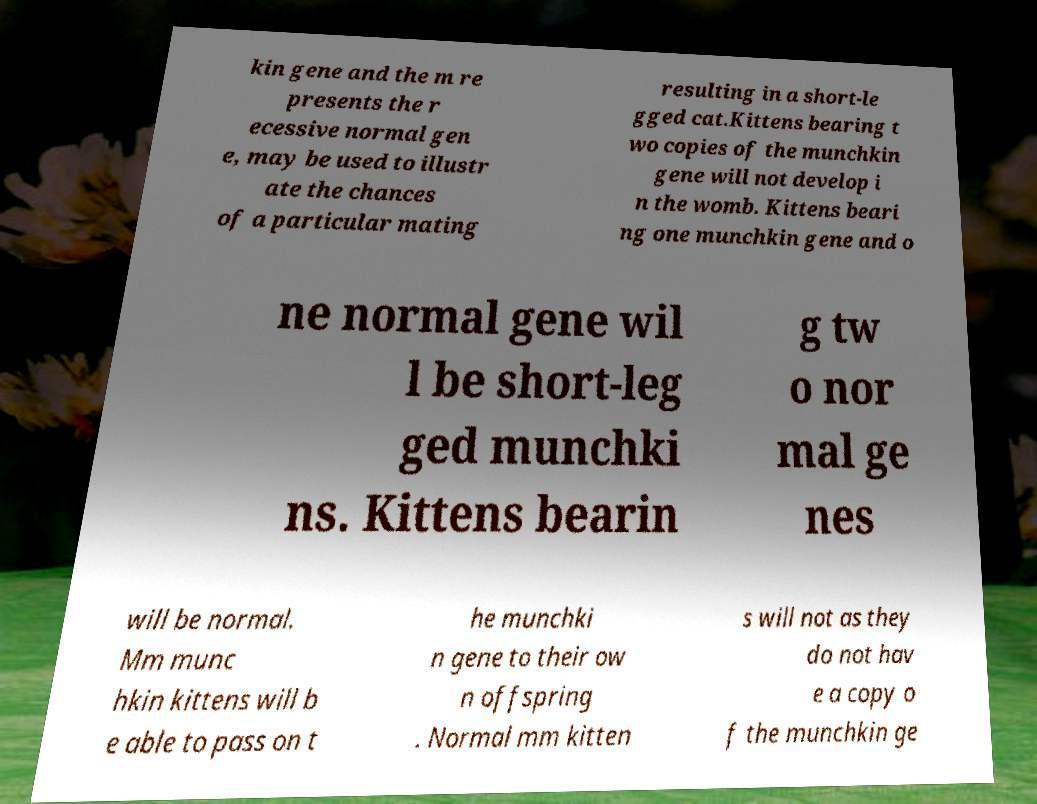Please identify and transcribe the text found in this image. kin gene and the m re presents the r ecessive normal gen e, may be used to illustr ate the chances of a particular mating resulting in a short-le gged cat.Kittens bearing t wo copies of the munchkin gene will not develop i n the womb. Kittens beari ng one munchkin gene and o ne normal gene wil l be short-leg ged munchki ns. Kittens bearin g tw o nor mal ge nes will be normal. Mm munc hkin kittens will b e able to pass on t he munchki n gene to their ow n offspring . Normal mm kitten s will not as they do not hav e a copy o f the munchkin ge 